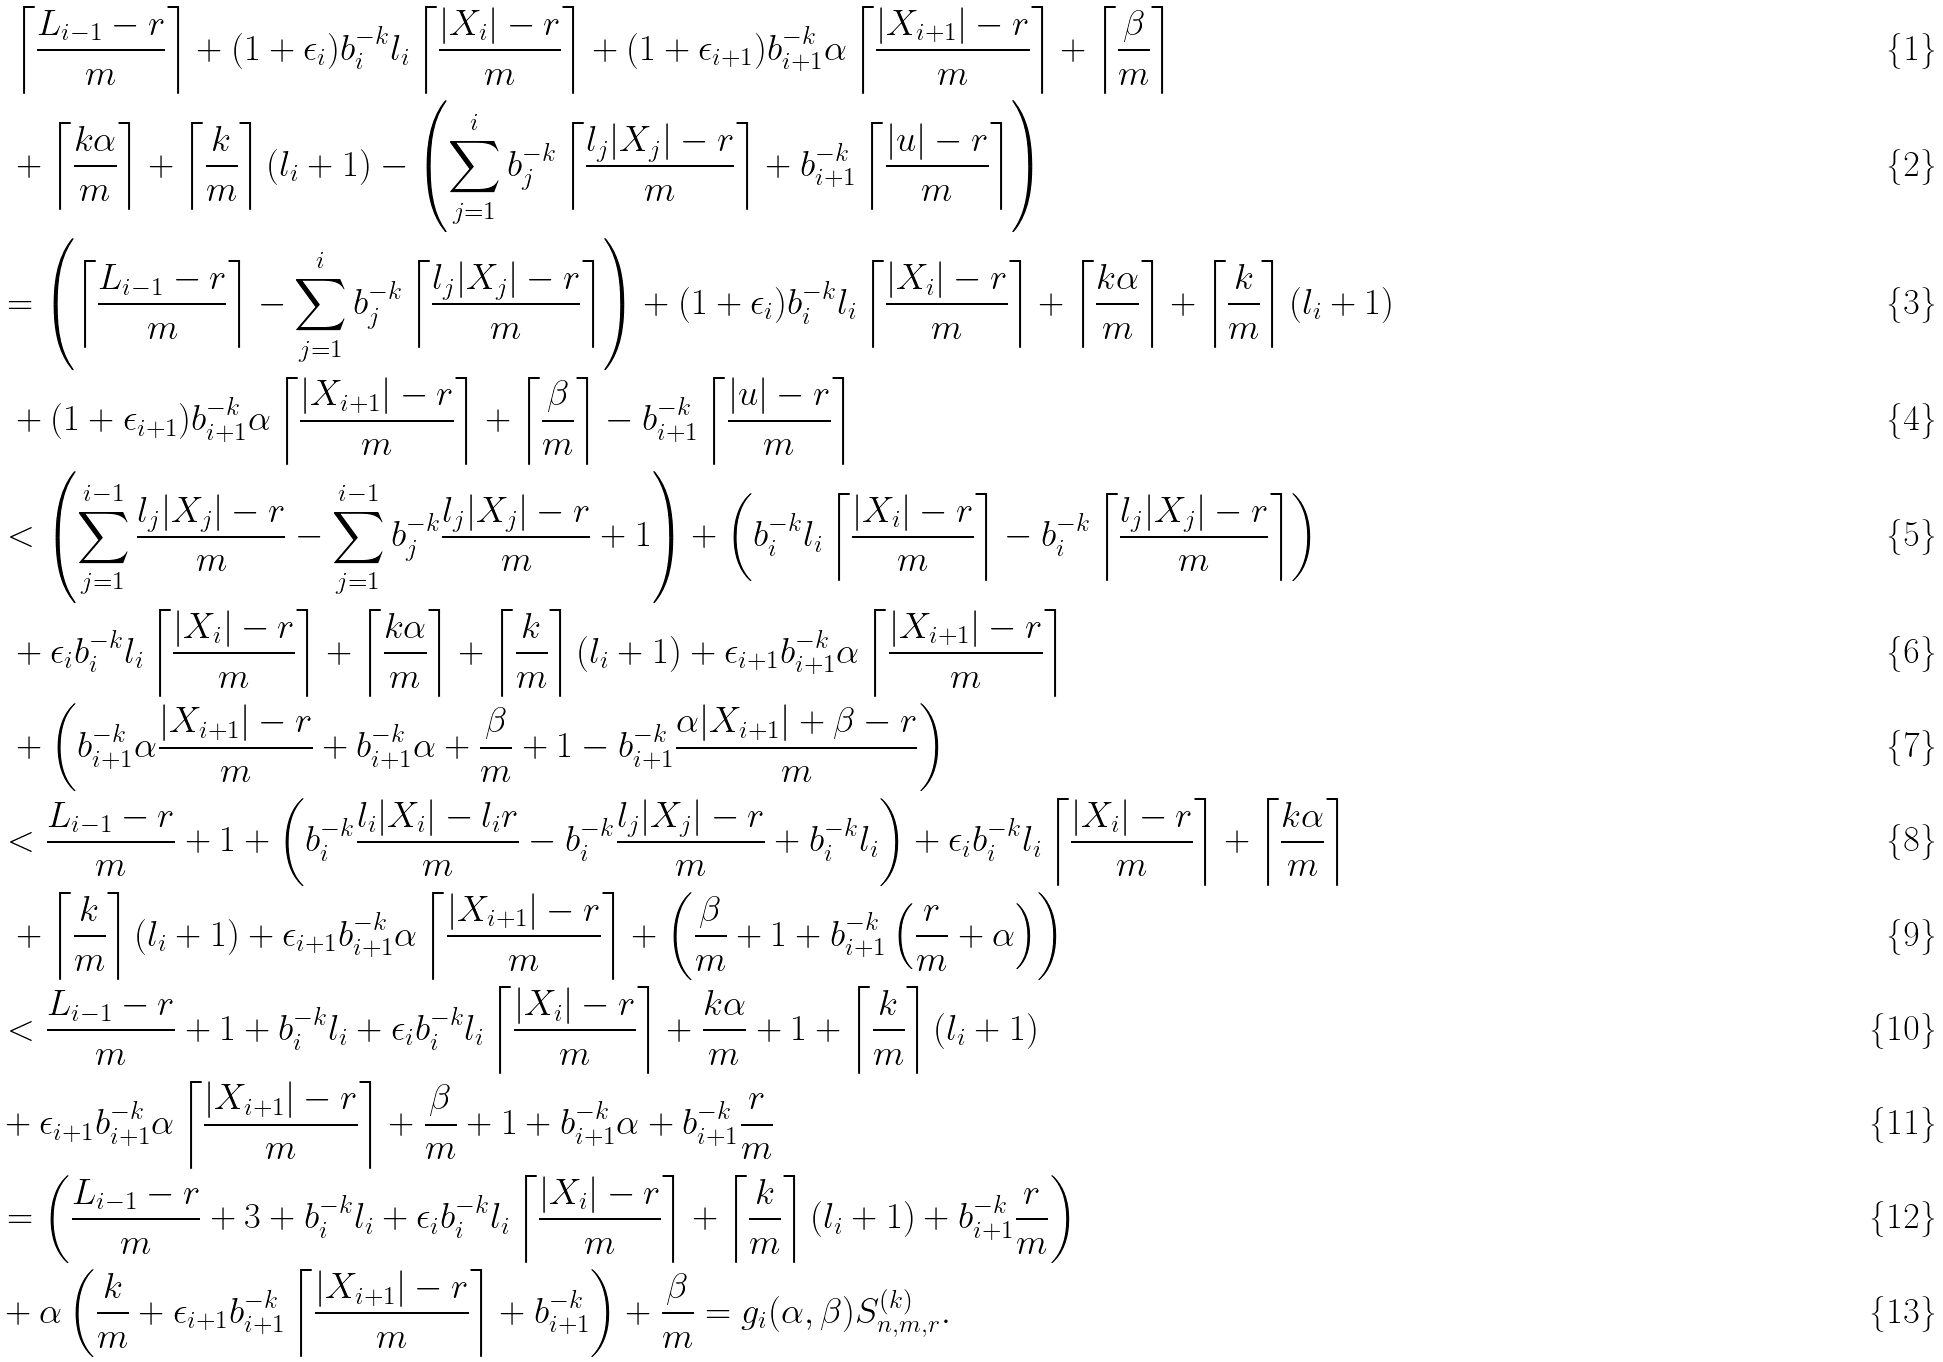<formula> <loc_0><loc_0><loc_500><loc_500>& \ \left \lceil \frac { L _ { i - 1 } - r } { m } \right \rceil + ( 1 + \epsilon _ { i } ) b _ { i } ^ { - k } l _ { i } \left \lceil \frac { | X _ { i } | - r } { m } \right \rceil + ( 1 + \epsilon _ { i + 1 } ) b _ { i + 1 } ^ { - k } \alpha \left \lceil \frac { | X _ { i + 1 } | - r } { m } \right \rceil + \left \lceil \frac { \beta } { m } \right \rceil \\ & \ + \left \lceil \frac { k \alpha } { m } \right \rceil + \left \lceil \frac { k } { m } \right \rceil ( l _ { i } + 1 ) - \left ( \sum _ { j = 1 } ^ { i } b _ { j } ^ { - k } \left \lceil \frac { l _ { j } | X _ { j } | - r } { m } \right \rceil + b _ { i + 1 } ^ { - k } \left \lceil \frac { | u | - r } { m } \right \rceil \right ) \\ & = \left ( \left \lceil \frac { L _ { i - 1 } - r } { m } \right \rceil - \sum _ { j = 1 } ^ { i } b _ { j } ^ { - k } \left \lceil \frac { l _ { j } | X _ { j } | - r } { m } \right \rceil \right ) + ( 1 + \epsilon _ { i } ) b _ { i } ^ { - k } l _ { i } \left \lceil \frac { | X _ { i } | - r } { m } \right \rceil + \left \lceil \frac { k \alpha } { m } \right \rceil + \left \lceil \frac { k } { m } \right \rceil ( l _ { i } + 1 ) \\ & \ + ( 1 + \epsilon _ { i + 1 } ) b _ { i + 1 } ^ { - k } \alpha \left \lceil \frac { | X _ { i + 1 } | - r } { m } \right \rceil + \left \lceil \frac { \beta } { m } \right \rceil - b _ { i + 1 } ^ { - k } \left \lceil \frac { | u | - r } { m } \right \rceil \\ & < \left ( \sum _ { j = 1 } ^ { i - 1 } \frac { l _ { j } | X _ { j } | - r } { m } - \sum _ { j = 1 } ^ { i - 1 } b _ { j } ^ { - k } \frac { l _ { j } | X _ { j } | - r } { m } + 1 \right ) + \left ( b _ { i } ^ { - k } l _ { i } \left \lceil \frac { | X _ { i } | - r } { m } \right \rceil - b _ { i } ^ { - k } \left \lceil \frac { l _ { j } | X _ { j } | - r } { m } \right \rceil \right ) \\ & \ + \epsilon _ { i } b _ { i } ^ { - k } l _ { i } \left \lceil \frac { | X _ { i } | - r } { m } \right \rceil + \left \lceil \frac { k \alpha } { m } \right \rceil + \left \lceil \frac { k } { m } \right \rceil ( l _ { i } + 1 ) + \epsilon _ { i + 1 } b _ { i + 1 } ^ { - k } \alpha \left \lceil \frac { | X _ { i + 1 } | - r } { m } \right \rceil \\ & \ + \left ( b _ { i + 1 } ^ { - k } \alpha \frac { | X _ { i + 1 } | - r } { m } + b _ { i + 1 } ^ { - k } \alpha + \frac { \beta } { m } + 1 - b _ { i + 1 } ^ { - k } \frac { \alpha | X _ { i + 1 } | + \beta - r } { m } \right ) \\ & < \frac { L _ { i - 1 } - r } { m } + 1 + \left ( b _ { i } ^ { - k } \frac { l _ { i } | X _ { i } | - l _ { i } r } { m } - b _ { i } ^ { - k } \frac { l _ { j } | X _ { j } | - r } { m } + b _ { i } ^ { - k } l _ { i } \right ) + \epsilon _ { i } b _ { i } ^ { - k } l _ { i } \left \lceil \frac { | X _ { i } | - r } { m } \right \rceil + \left \lceil \frac { k \alpha } { m } \right \rceil \\ & \ + \left \lceil \frac { k } { m } \right \rceil ( l _ { i } + 1 ) + \epsilon _ { i + 1 } b _ { i + 1 } ^ { - k } \alpha \left \lceil \frac { | X _ { i + 1 } | - r } { m } \right \rceil + \left ( \frac { \beta } { m } + 1 + b _ { i + 1 } ^ { - k } \left ( \frac { r } { m } + \alpha \right ) \right ) \\ & < \frac { L _ { i - 1 } - r } { m } + 1 + b _ { i } ^ { - k } l _ { i } + \epsilon _ { i } b _ { i } ^ { - k } l _ { i } \left \lceil \frac { | X _ { i } | - r } { m } \right \rceil + \frac { k \alpha } { m } + 1 + \left \lceil \frac { k } { m } \right \rceil ( l _ { i } + 1 ) \\ & + \epsilon _ { i + 1 } b _ { i + 1 } ^ { - k } \alpha \left \lceil \frac { | X _ { i + 1 } | - r } { m } \right \rceil + \frac { \beta } { m } + 1 + b _ { i + 1 } ^ { - k } \alpha + b _ { i + 1 } ^ { - k } \frac { r } { m } \\ & = \left ( \frac { L _ { i - 1 } - r } { m } + 3 + b _ { i } ^ { - k } l _ { i } + \epsilon _ { i } b _ { i } ^ { - k } l _ { i } \left \lceil \frac { | X _ { i } | - r } { m } \right \rceil + \left \lceil \frac { k } { m } \right \rceil ( l _ { i } + 1 ) + b _ { i + 1 } ^ { - k } \frac { r } { m } \right ) \\ & + \alpha \left ( \frac { k } { m } + \epsilon _ { i + 1 } b _ { i + 1 } ^ { - k } \left \lceil \frac { | X _ { i + 1 } | - r } { m } \right \rceil + b _ { i + 1 } ^ { - k } \right ) + \frac { \beta } { m } = g _ { i } ( \alpha , \beta ) { S } _ { n , m , r } ^ { ( k ) } .</formula> 